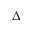<formula> <loc_0><loc_0><loc_500><loc_500>\Delta</formula> 